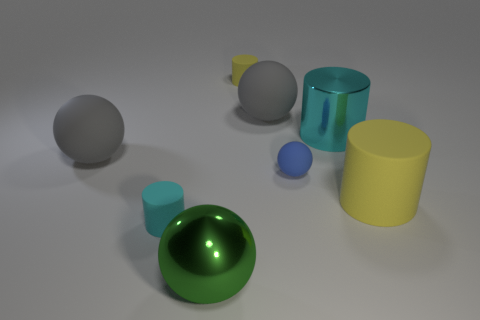Are there any large rubber spheres that have the same color as the large metallic cylinder?
Offer a very short reply. No. Do the large shiny thing that is in front of the small cyan cylinder and the cyan rubber thing that is in front of the blue matte sphere have the same shape?
Provide a short and direct response. No. Is there a small cyan cylinder made of the same material as the tiny yellow cylinder?
Your response must be concise. Yes. How many yellow things are either shiny spheres or matte balls?
Provide a short and direct response. 0. How big is the ball that is both left of the small yellow cylinder and behind the green metal object?
Offer a very short reply. Large. Are there more metallic balls in front of the large green shiny sphere than big metal spheres?
Offer a terse response. No. How many cylinders are either small cyan metallic things or large yellow things?
Provide a short and direct response. 1. There is a big thing that is both on the left side of the tiny yellow rubber object and behind the metallic sphere; what shape is it?
Provide a short and direct response. Sphere. Is the number of cyan rubber objects that are behind the cyan shiny object the same as the number of tiny rubber spheres in front of the big green object?
Keep it short and to the point. Yes. How many things are tiny rubber things or big matte cylinders?
Provide a short and direct response. 4. 